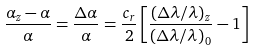<formula> <loc_0><loc_0><loc_500><loc_500>\frac { \alpha _ { z } - \alpha } { \alpha } = \frac { \Delta \alpha } { \alpha } = \frac { c _ { r } } { 2 } \left [ \frac { \left ( \Delta \lambda / \lambda \right ) _ { z } } { \left ( \Delta \lambda / \lambda \right ) _ { 0 } } - 1 \right ]</formula> 